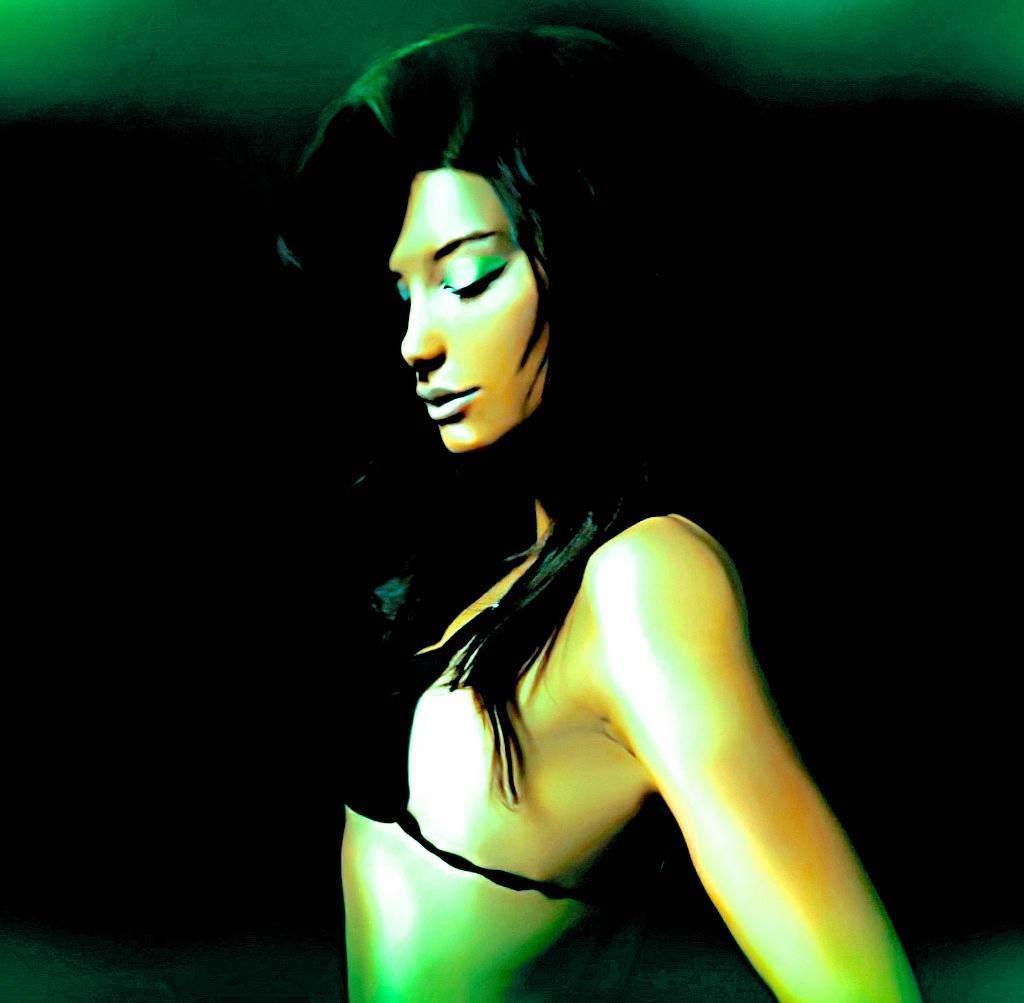Please provide a concise description of this image. Here we can see picture of a woman and there is a dark background. 